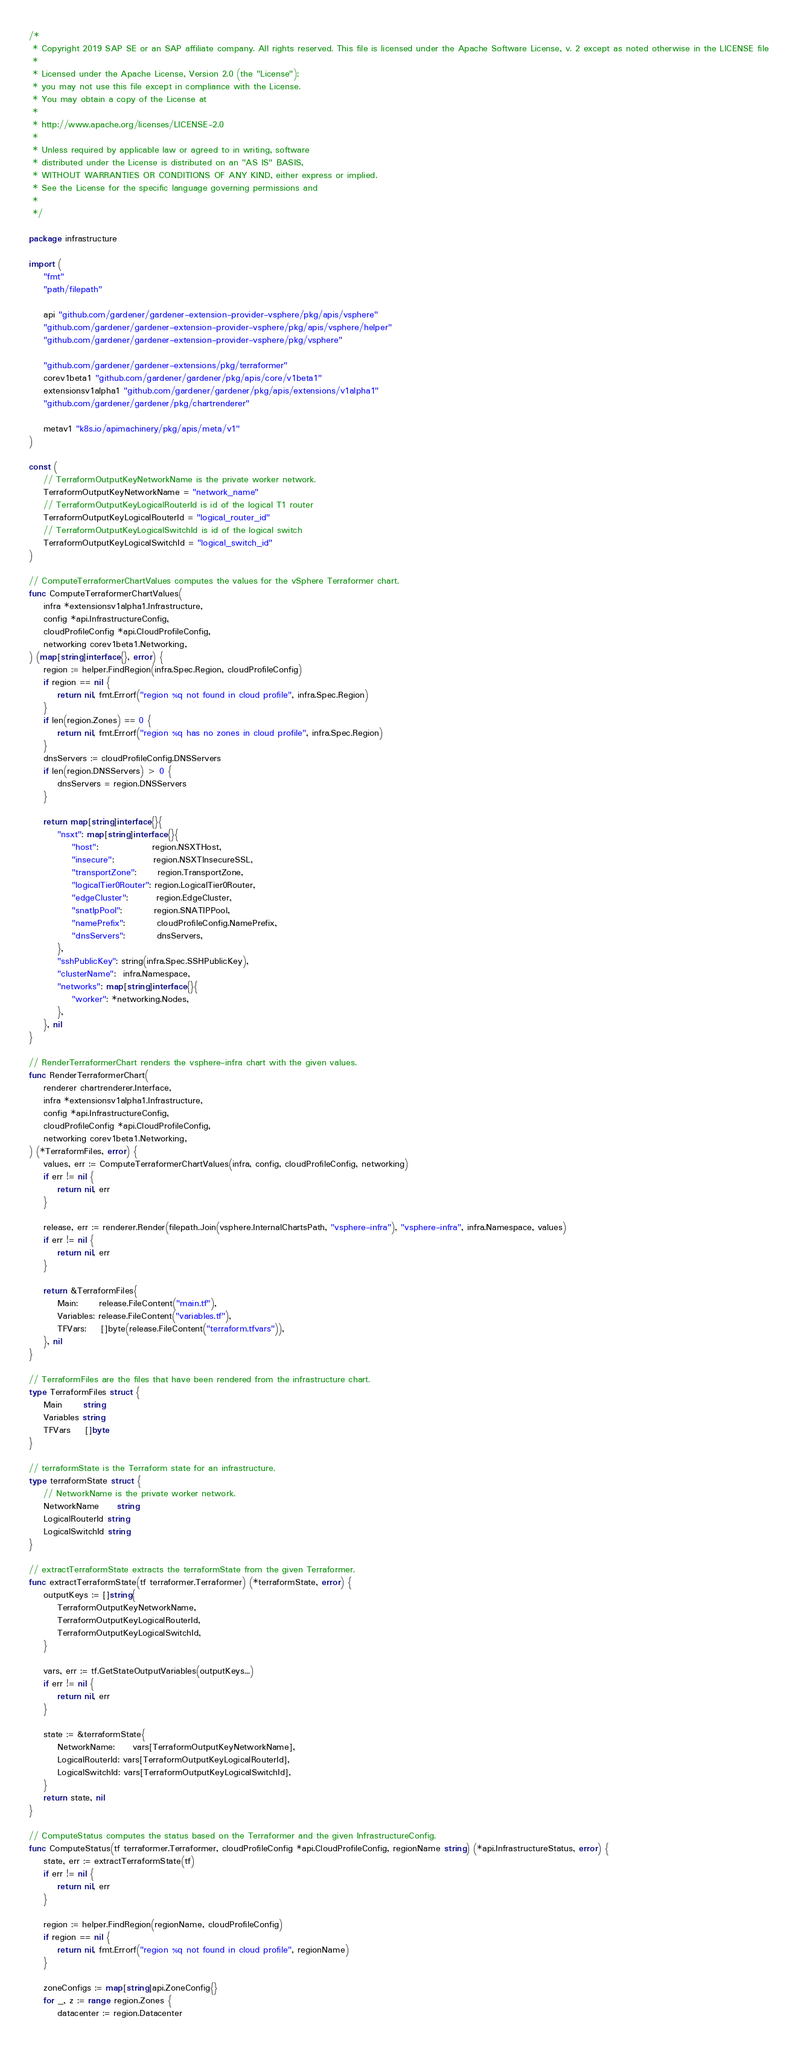<code> <loc_0><loc_0><loc_500><loc_500><_Go_>/*
 * Copyright 2019 SAP SE or an SAP affiliate company. All rights reserved. This file is licensed under the Apache Software License, v. 2 except as noted otherwise in the LICENSE file
 *
 * Licensed under the Apache License, Version 2.0 (the "License");
 * you may not use this file except in compliance with the License.
 * You may obtain a copy of the License at
 *
 * http://www.apache.org/licenses/LICENSE-2.0
 *
 * Unless required by applicable law or agreed to in writing, software
 * distributed under the License is distributed on an "AS IS" BASIS,
 * WITHOUT WARRANTIES OR CONDITIONS OF ANY KIND, either express or implied.
 * See the License for the specific language governing permissions and
 *
 */

package infrastructure

import (
	"fmt"
	"path/filepath"

	api "github.com/gardener/gardener-extension-provider-vsphere/pkg/apis/vsphere"
	"github.com/gardener/gardener-extension-provider-vsphere/pkg/apis/vsphere/helper"
	"github.com/gardener/gardener-extension-provider-vsphere/pkg/vsphere"

	"github.com/gardener/gardener-extensions/pkg/terraformer"
	corev1beta1 "github.com/gardener/gardener/pkg/apis/core/v1beta1"
	extensionsv1alpha1 "github.com/gardener/gardener/pkg/apis/extensions/v1alpha1"
	"github.com/gardener/gardener/pkg/chartrenderer"

	metav1 "k8s.io/apimachinery/pkg/apis/meta/v1"
)

const (
	// TerraformOutputKeyNetworkName is the private worker network.
	TerraformOutputKeyNetworkName = "network_name"
	// TerraformOutputKeyLogicalRouterId is id of the logical T1 router
	TerraformOutputKeyLogicalRouterId = "logical_router_id"
	// TerraformOutputKeyLogicalSwitchId is id of the logical switch
	TerraformOutputKeyLogicalSwitchId = "logical_switch_id"
)

// ComputeTerraformerChartValues computes the values for the vSphere Terraformer chart.
func ComputeTerraformerChartValues(
	infra *extensionsv1alpha1.Infrastructure,
	config *api.InfrastructureConfig,
	cloudProfileConfig *api.CloudProfileConfig,
	networking corev1beta1.Networking,
) (map[string]interface{}, error) {
	region := helper.FindRegion(infra.Spec.Region, cloudProfileConfig)
	if region == nil {
		return nil, fmt.Errorf("region %q not found in cloud profile", infra.Spec.Region)
	}
	if len(region.Zones) == 0 {
		return nil, fmt.Errorf("region %q has no zones in cloud profile", infra.Spec.Region)
	}
	dnsServers := cloudProfileConfig.DNSServers
	if len(region.DNSServers) > 0 {
		dnsServers = region.DNSServers
	}

	return map[string]interface{}{
		"nsxt": map[string]interface{}{
			"host":               region.NSXTHost,
			"insecure":           region.NSXTInsecureSSL,
			"transportZone":      region.TransportZone,
			"logicalTier0Router": region.LogicalTier0Router,
			"edgeCluster":        region.EdgeCluster,
			"snatIpPool":         region.SNATIPPool,
			"namePrefix":         cloudProfileConfig.NamePrefix,
			"dnsServers":         dnsServers,
		},
		"sshPublicKey": string(infra.Spec.SSHPublicKey),
		"clusterName":  infra.Namespace,
		"networks": map[string]interface{}{
			"worker": *networking.Nodes,
		},
	}, nil
}

// RenderTerraformerChart renders the vsphere-infra chart with the given values.
func RenderTerraformerChart(
	renderer chartrenderer.Interface,
	infra *extensionsv1alpha1.Infrastructure,
	config *api.InfrastructureConfig,
	cloudProfileConfig *api.CloudProfileConfig,
	networking corev1beta1.Networking,
) (*TerraformFiles, error) {
	values, err := ComputeTerraformerChartValues(infra, config, cloudProfileConfig, networking)
	if err != nil {
		return nil, err
	}

	release, err := renderer.Render(filepath.Join(vsphere.InternalChartsPath, "vsphere-infra"), "vsphere-infra", infra.Namespace, values)
	if err != nil {
		return nil, err
	}

	return &TerraformFiles{
		Main:      release.FileContent("main.tf"),
		Variables: release.FileContent("variables.tf"),
		TFVars:    []byte(release.FileContent("terraform.tfvars")),
	}, nil
}

// TerraformFiles are the files that have been rendered from the infrastructure chart.
type TerraformFiles struct {
	Main      string
	Variables string
	TFVars    []byte
}

// terraformState is the Terraform state for an infrastructure.
type terraformState struct {
	// NetworkName is the private worker network.
	NetworkName     string
	LogicalRouterId string
	LogicalSwitchId string
}

// extractTerraformState extracts the terraformState from the given Terraformer.
func extractTerraformState(tf terraformer.Terraformer) (*terraformState, error) {
	outputKeys := []string{
		TerraformOutputKeyNetworkName,
		TerraformOutputKeyLogicalRouterId,
		TerraformOutputKeyLogicalSwitchId,
	}

	vars, err := tf.GetStateOutputVariables(outputKeys...)
	if err != nil {
		return nil, err
	}

	state := &terraformState{
		NetworkName:     vars[TerraformOutputKeyNetworkName],
		LogicalRouterId: vars[TerraformOutputKeyLogicalRouterId],
		LogicalSwitchId: vars[TerraformOutputKeyLogicalSwitchId],
	}
	return state, nil
}

// ComputeStatus computes the status based on the Terraformer and the given InfrastructureConfig.
func ComputeStatus(tf terraformer.Terraformer, cloudProfileConfig *api.CloudProfileConfig, regionName string) (*api.InfrastructureStatus, error) {
	state, err := extractTerraformState(tf)
	if err != nil {
		return nil, err
	}

	region := helper.FindRegion(regionName, cloudProfileConfig)
	if region == nil {
		return nil, fmt.Errorf("region %q not found in cloud profile", regionName)
	}

	zoneConfigs := map[string]api.ZoneConfig{}
	for _, z := range region.Zones {
		datacenter := region.Datacenter</code> 